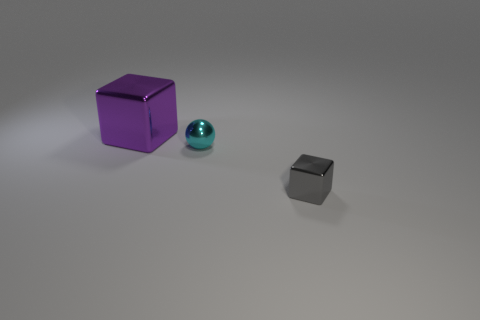There is a metal block that is on the right side of the large thing on the left side of the cube in front of the large purple shiny cube; what color is it?
Your response must be concise. Gray. The shiny ball has what color?
Your answer should be very brief. Cyan. Is the number of cyan spheres that are right of the cyan object greater than the number of metal objects that are in front of the gray shiny cube?
Your answer should be very brief. No. Does the large purple object have the same shape as the small metallic object that is left of the small block?
Offer a terse response. No. There is a metallic thing in front of the small cyan metal thing; does it have the same size as the metallic block that is on the left side of the gray metallic cube?
Offer a very short reply. No. Is there a small cyan metallic object that is in front of the tiny object that is behind the cube that is to the right of the purple metal cube?
Offer a terse response. No. Are there fewer small cyan objects in front of the small ball than blocks behind the gray object?
Your answer should be very brief. Yes. What is the shape of the tiny cyan object that is the same material as the large purple object?
Provide a short and direct response. Sphere. There is a object behind the tiny metallic object to the left of the cube right of the big block; how big is it?
Your answer should be compact. Large. Is the number of small balls greater than the number of small purple blocks?
Ensure brevity in your answer.  Yes. 